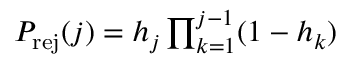Convert formula to latex. <formula><loc_0><loc_0><loc_500><loc_500>\begin{array} { r } { P _ { r e j } ( j ) = h _ { j } \prod _ { k = 1 } ^ { j - 1 } ( 1 - h _ { k } ) } \end{array}</formula> 